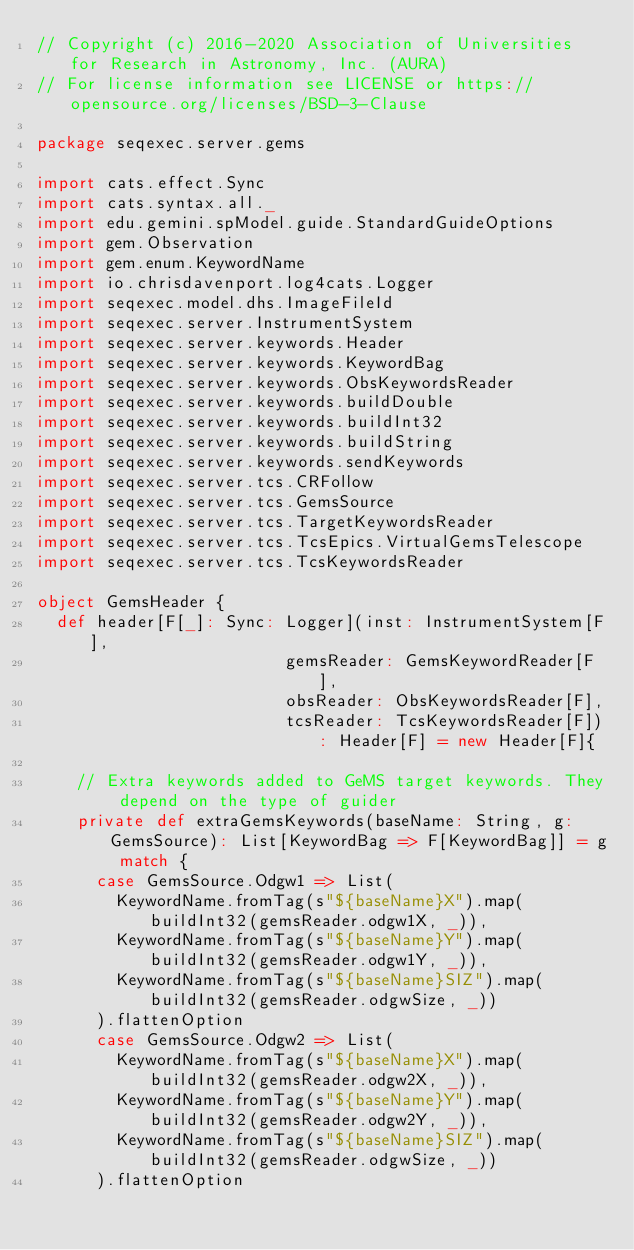<code> <loc_0><loc_0><loc_500><loc_500><_Scala_>// Copyright (c) 2016-2020 Association of Universities for Research in Astronomy, Inc. (AURA)
// For license information see LICENSE or https://opensource.org/licenses/BSD-3-Clause

package seqexec.server.gems

import cats.effect.Sync
import cats.syntax.all._
import edu.gemini.spModel.guide.StandardGuideOptions
import gem.Observation
import gem.enum.KeywordName
import io.chrisdavenport.log4cats.Logger
import seqexec.model.dhs.ImageFileId
import seqexec.server.InstrumentSystem
import seqexec.server.keywords.Header
import seqexec.server.keywords.KeywordBag
import seqexec.server.keywords.ObsKeywordsReader
import seqexec.server.keywords.buildDouble
import seqexec.server.keywords.buildInt32
import seqexec.server.keywords.buildString
import seqexec.server.keywords.sendKeywords
import seqexec.server.tcs.CRFollow
import seqexec.server.tcs.GemsSource
import seqexec.server.tcs.TargetKeywordsReader
import seqexec.server.tcs.TcsEpics.VirtualGemsTelescope
import seqexec.server.tcs.TcsKeywordsReader

object GemsHeader {
  def header[F[_]: Sync: Logger](inst: InstrumentSystem[F],
                         gemsReader: GemsKeywordReader[F],
                         obsReader: ObsKeywordsReader[F],
                         tcsReader: TcsKeywordsReader[F]): Header[F] = new Header[F]{

    // Extra keywords added to GeMS target keywords. They depend on the type of guider
    private def extraGemsKeywords(baseName: String, g: GemsSource): List[KeywordBag => F[KeywordBag]] = g match {
      case GemsSource.Odgw1 => List(
        KeywordName.fromTag(s"${baseName}X").map(buildInt32(gemsReader.odgw1X, _)),
        KeywordName.fromTag(s"${baseName}Y").map(buildInt32(gemsReader.odgw1Y, _)),
        KeywordName.fromTag(s"${baseName}SIZ").map(buildInt32(gemsReader.odgwSize, _))
      ).flattenOption
      case GemsSource.Odgw2 => List(
        KeywordName.fromTag(s"${baseName}X").map(buildInt32(gemsReader.odgw2X, _)),
        KeywordName.fromTag(s"${baseName}Y").map(buildInt32(gemsReader.odgw2Y, _)),
        KeywordName.fromTag(s"${baseName}SIZ").map(buildInt32(gemsReader.odgwSize, _))
      ).flattenOption</code> 